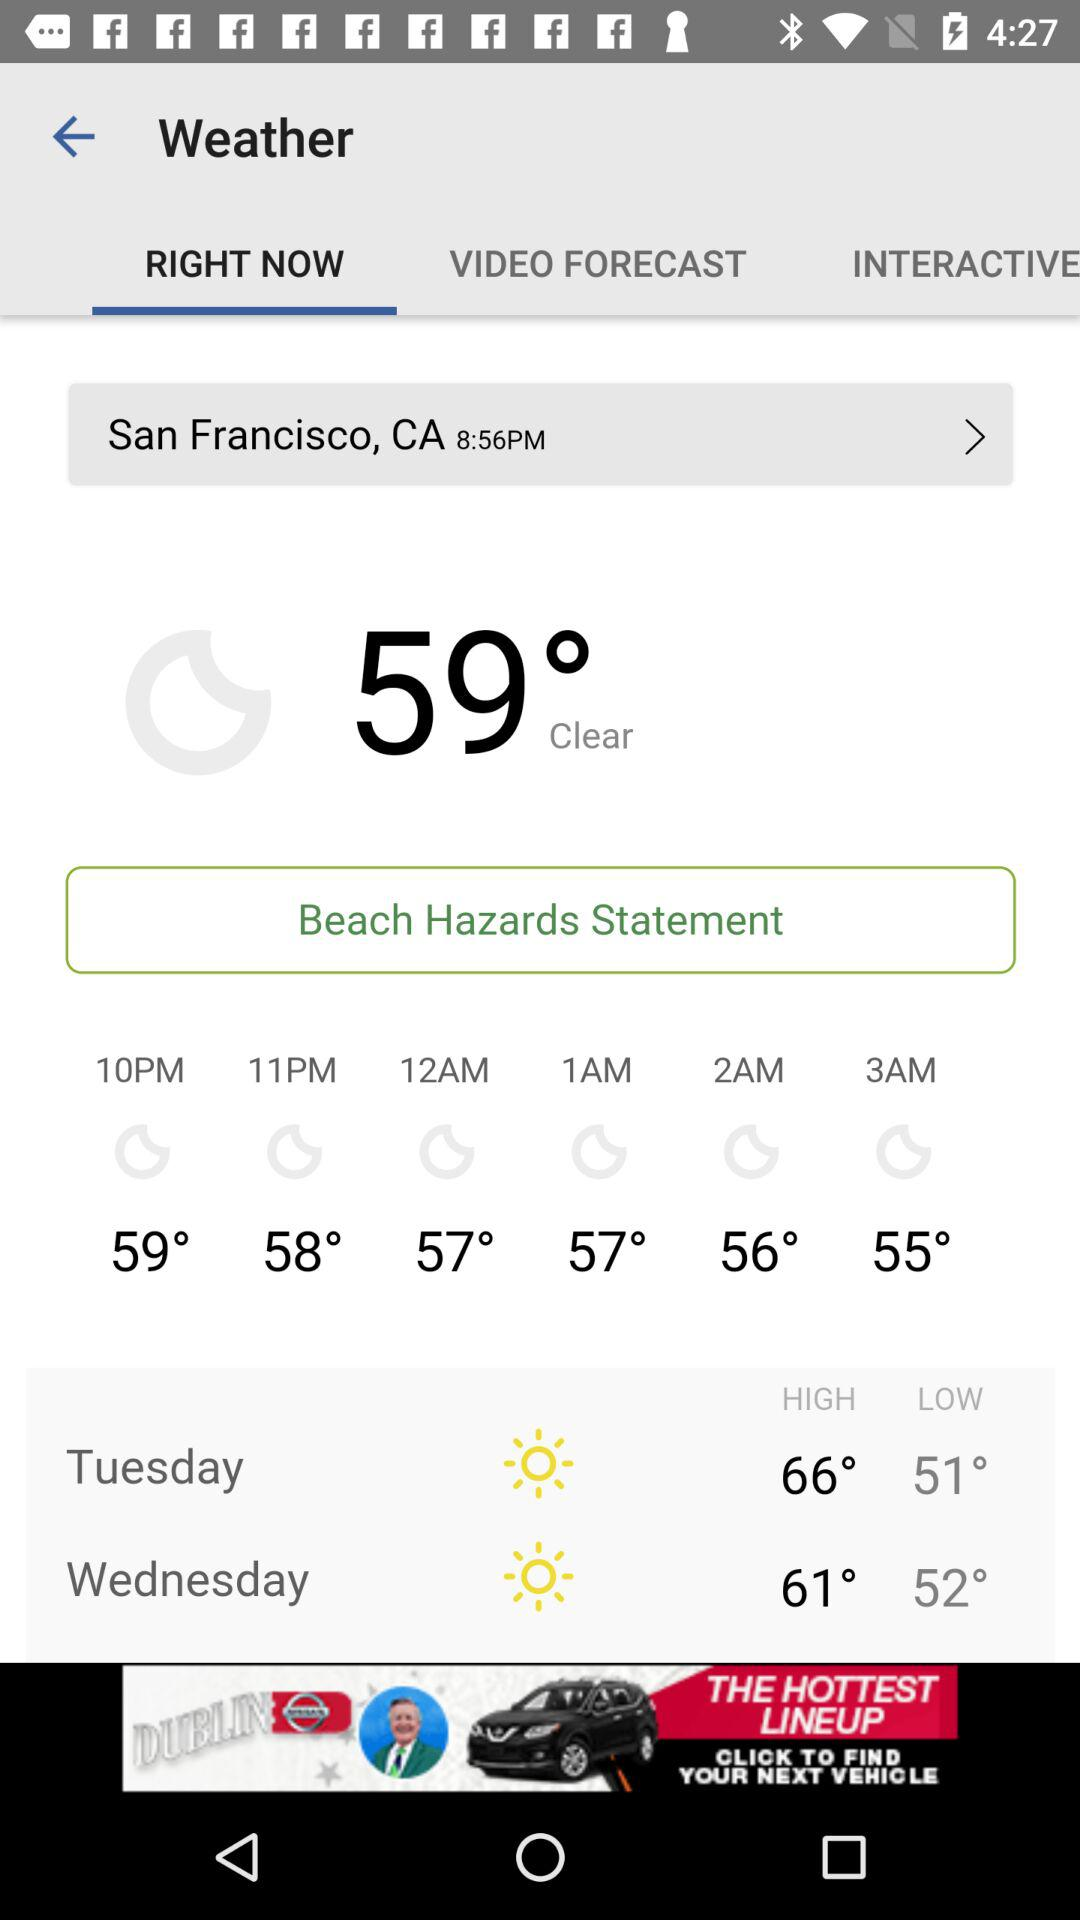What is the temperature at 11 p.m.? The temperature is 58°. 